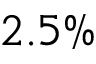<formula> <loc_0><loc_0><loc_500><loc_500>2 . 5 \%</formula> 